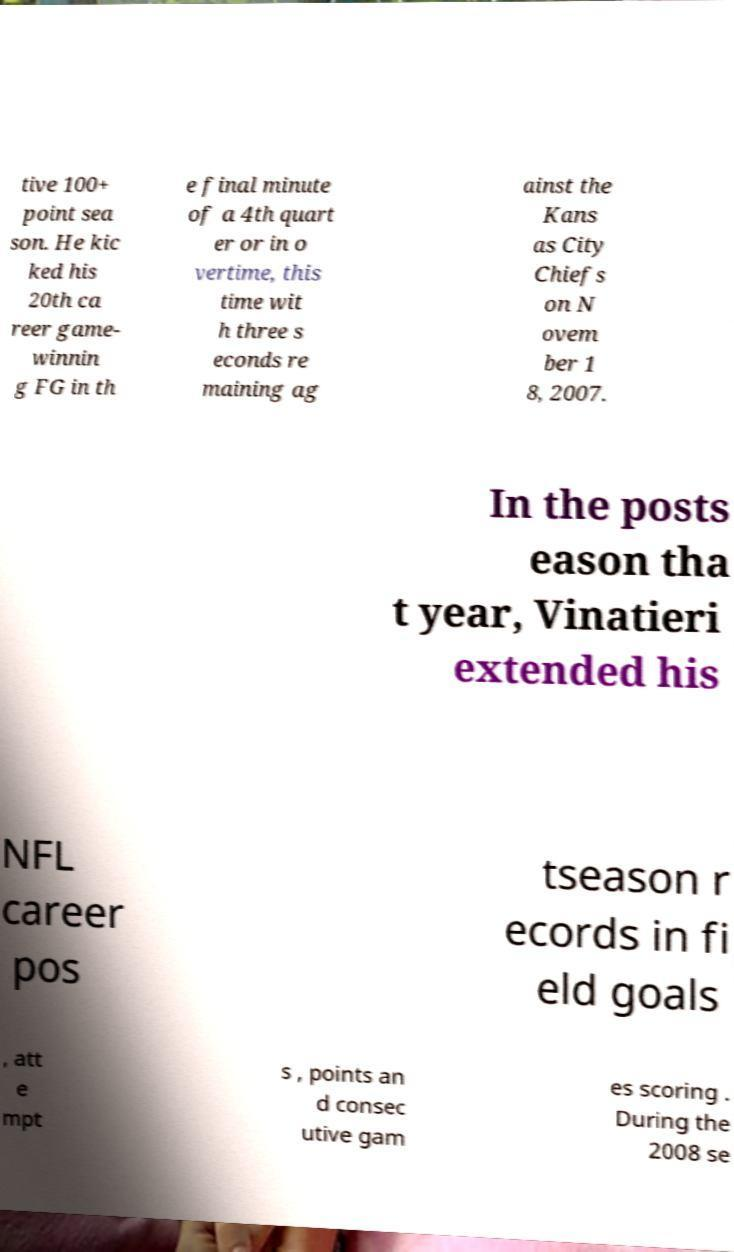Can you accurately transcribe the text from the provided image for me? tive 100+ point sea son. He kic ked his 20th ca reer game- winnin g FG in th e final minute of a 4th quart er or in o vertime, this time wit h three s econds re maining ag ainst the Kans as City Chiefs on N ovem ber 1 8, 2007. In the posts eason tha t year, Vinatieri extended his NFL career pos tseason r ecords in fi eld goals , att e mpt s , points an d consec utive gam es scoring . During the 2008 se 